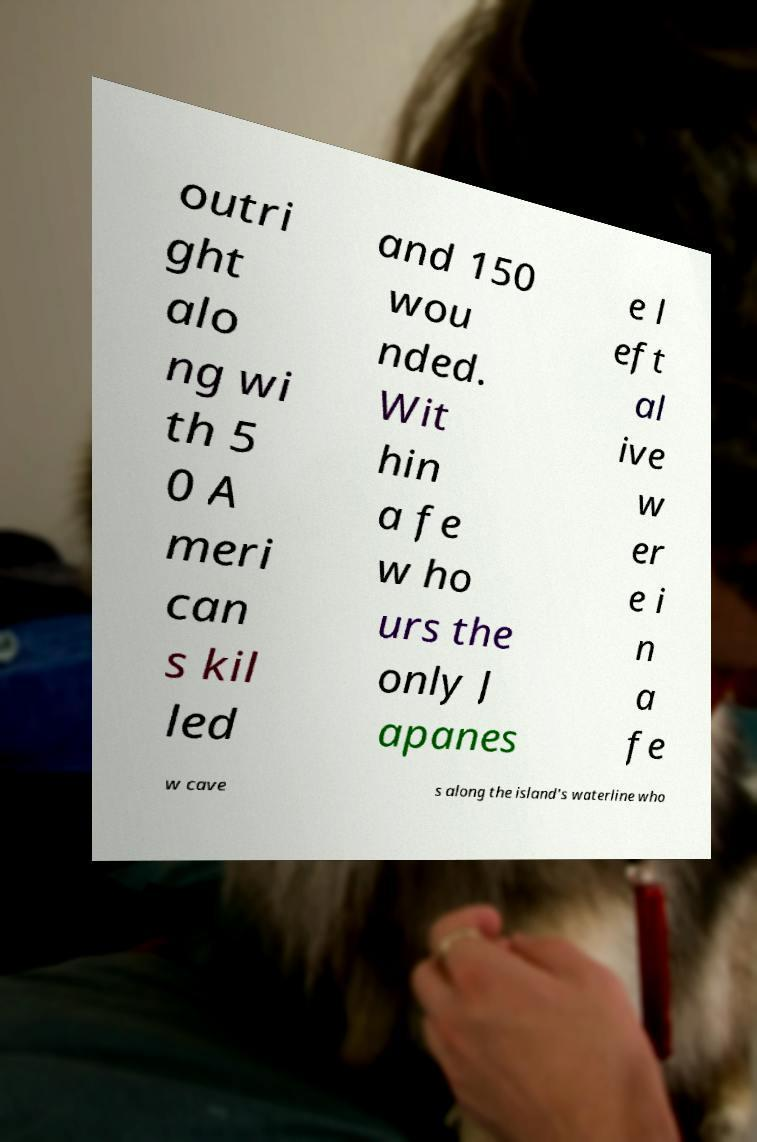For documentation purposes, I need the text within this image transcribed. Could you provide that? outri ght alo ng wi th 5 0 A meri can s kil led and 150 wou nded. Wit hin a fe w ho urs the only J apanes e l eft al ive w er e i n a fe w cave s along the island's waterline who 